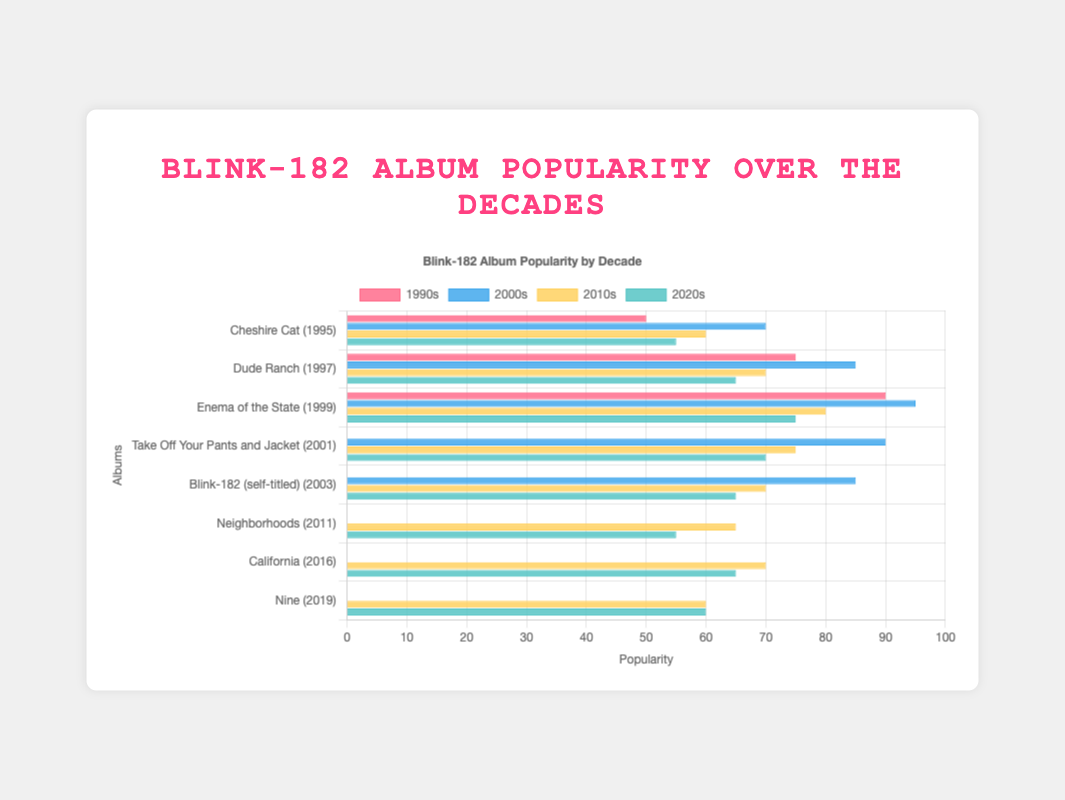What's the most popular album in the 1990s? The bars representing the different albums from the 1990s show "Enema of the State" has the highest popularity score.
Answer: Enema of the State Which decade shows the highest popularity for "Neighborhoods"? From the grouped bar chart, "Neighborhoods" has bars only in 2010s and 2020s. The bar for 2010s is taller, indicating higher popularity.
Answer: 2010s Compare the popularity of "Dude Ranch" in the 1990s and 2000s. Which is higher? By observing the bars for "Dude Ranch", the bar representing the 2000s is higher than the bar for the 1990s, indicating higher popularity in the 2000s.
Answer: 2000s Calculate the total popularity of "Take Off Your Pants and Jacket" across all decades. Sum the popularity scores from the bars for the four decades: 0 (1990s) + 90 (2000s) + 75 (2010s) + 70 (2020s). The total is 235.
Answer: 235 By how much did the popularity of "Enema of the State" change from the 2010s to the 2020s? The popularity in the 2010s is 80, and in the 2020s is 75. Subtract the latter from the former: 80 - 75 = 5.
Answer: 5 Which album has the least popularity in the 2020s? The shortest bar in the 2020s section corresponds to "Neighborhoods", with a score of 55.
Answer: Neighborhoods Identify the album that gained popularity in every subsequent decade after its release. "Cheshire Cat" shows increasing popularity from the 1990s to the 2000s but it decreases afterwards, and none of the other albums show a consistent increase in every decade. Thus, there is no album that fits this criteria.
Answer: None Which album released in the 2010s has the highest popularity in the 2020s? Among the albums released in the 2010s - "Neighborhoods," "California," and "Nine" - "California" has the highest popularity in the 2020s (65).
Answer: California What's the average popularity of all albums in the 2000s? Sum the popularity scores of all albums in the 2000s: 70 (Cheshire Cat) + 85 (Dude Ranch) + 95 (Enema of the State) + 90 (Take Off Your Pants and Jacket) + 85 (Blink-182) + 0 (Neighborhoods) + 0 (California) + 0 (Nine) = 425. There are 8 albums, so the average is 425/8 = 53.125.
Answer: 53.125 